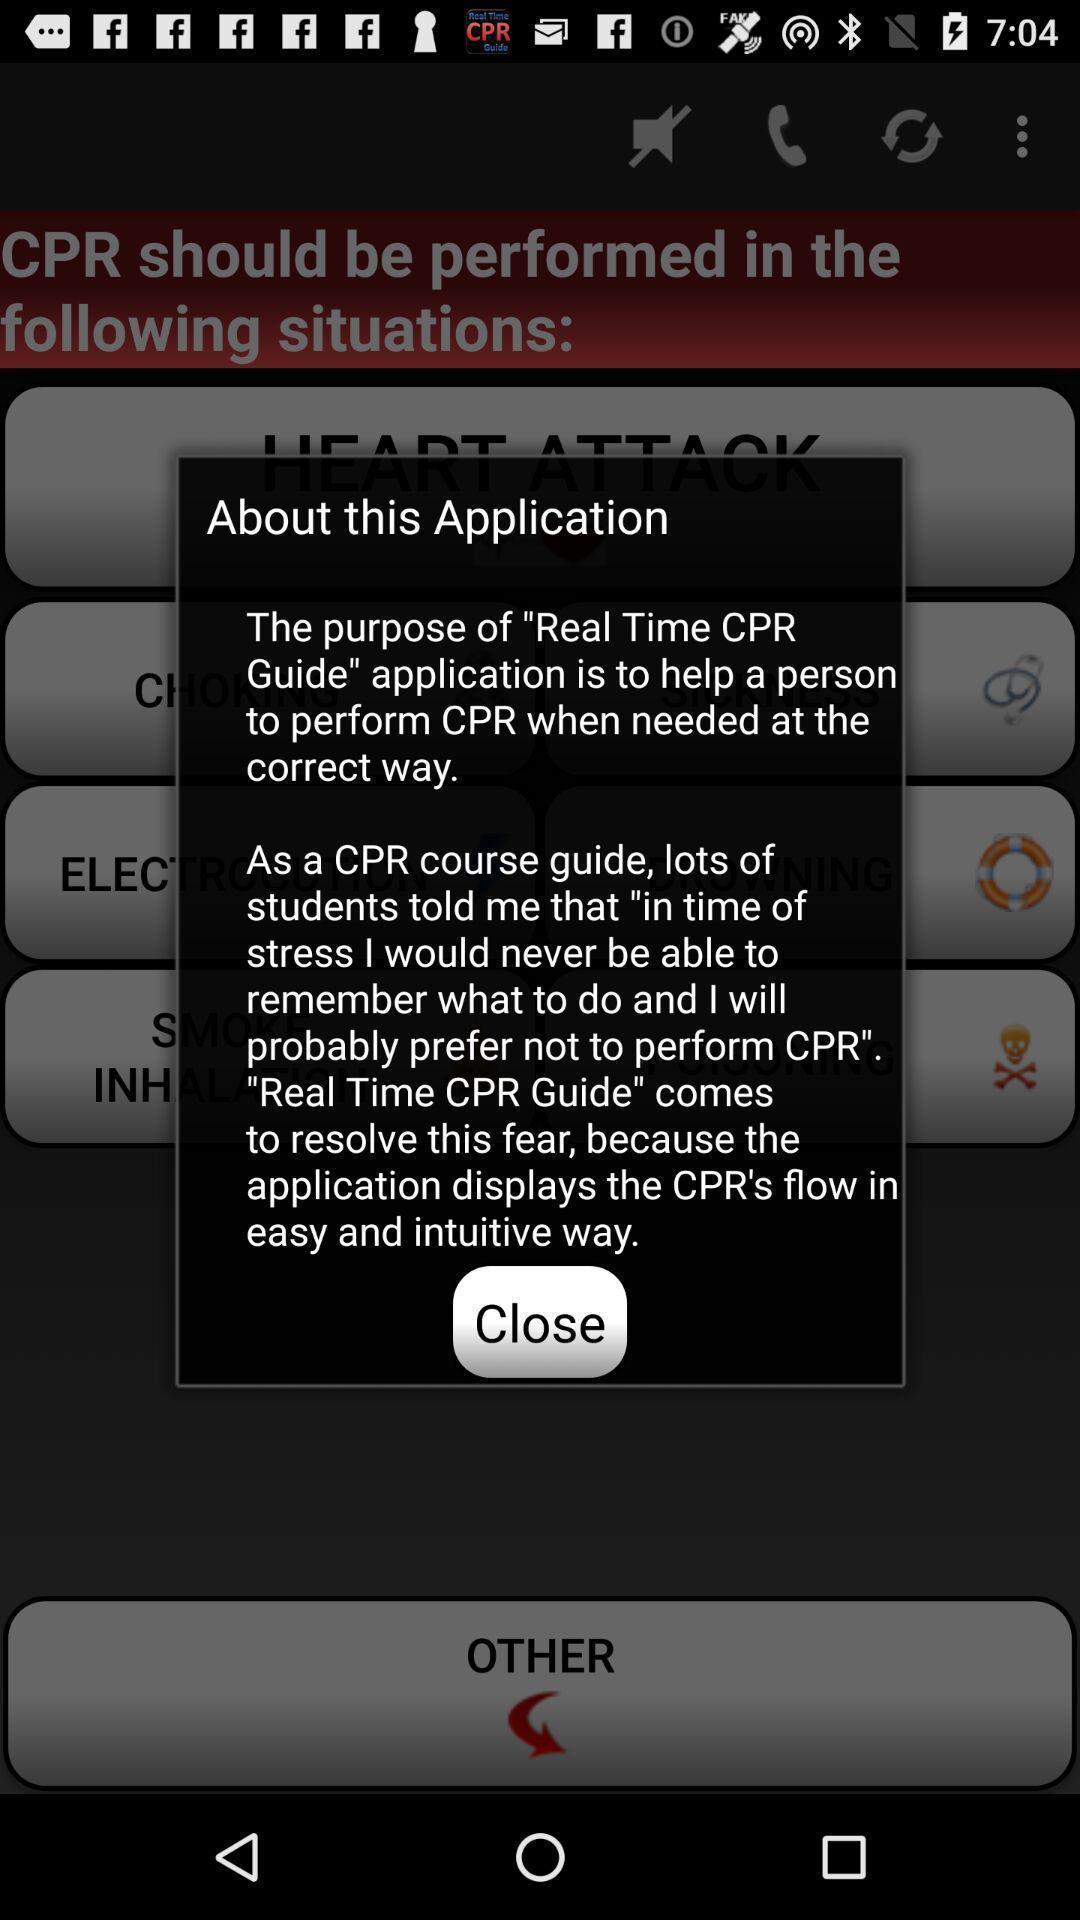What is the overall content of this screenshot? Pop up window displaying about the app. 